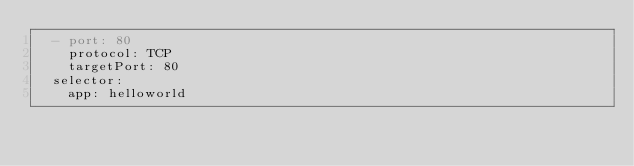<code> <loc_0><loc_0><loc_500><loc_500><_YAML_>  - port: 80
    protocol: TCP
    targetPort: 80
  selector:
    app: helloworld
</code> 